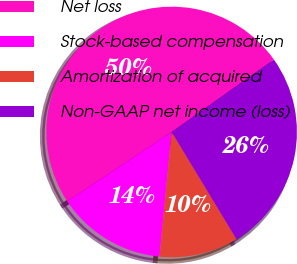Convert chart. <chart><loc_0><loc_0><loc_500><loc_500><pie_chart><fcel>Net loss<fcel>Stock-based compensation<fcel>Amortization of acquired<fcel>Non-GAAP net income (loss)<nl><fcel>49.51%<fcel>14.13%<fcel>10.2%<fcel>26.15%<nl></chart> 